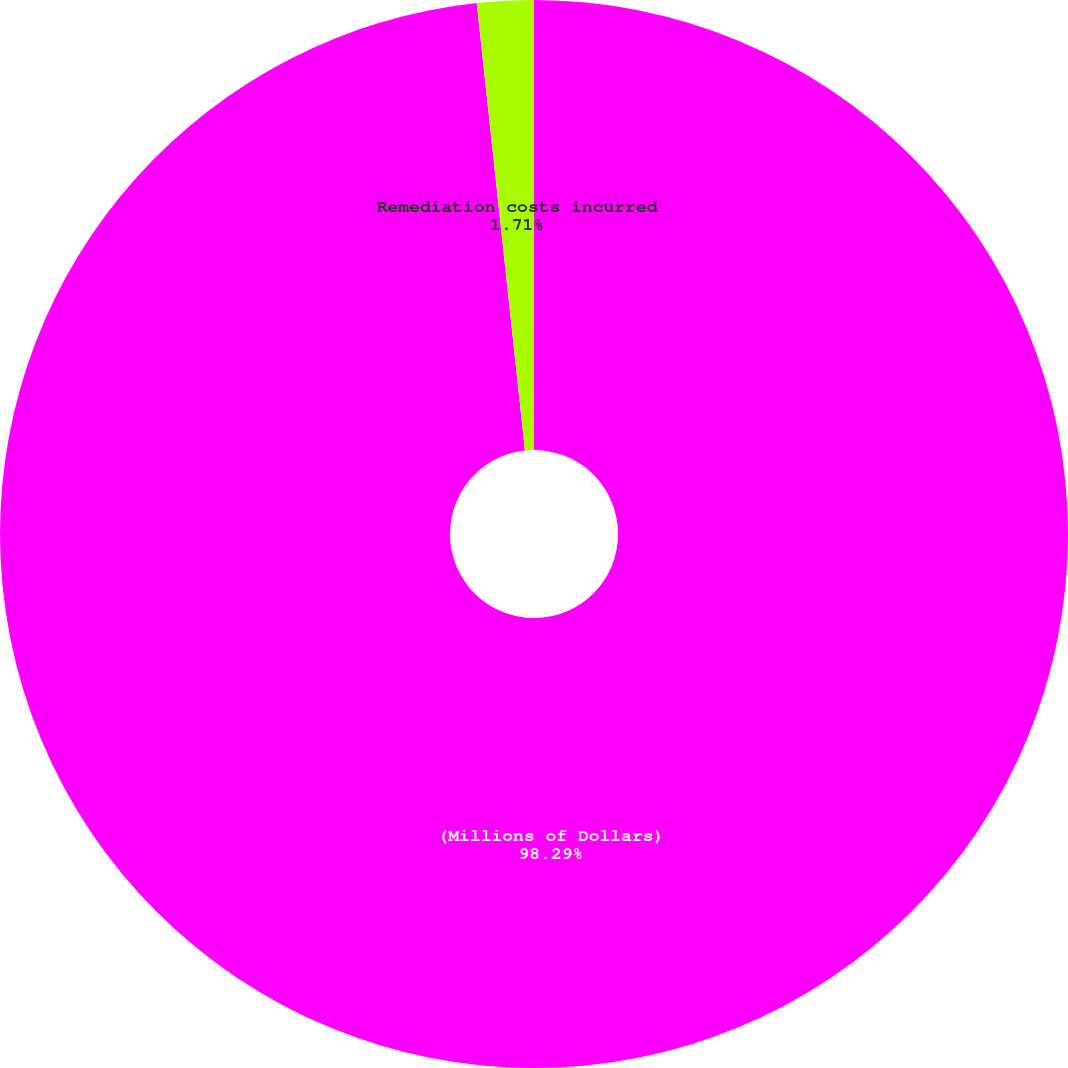Convert chart to OTSL. <chart><loc_0><loc_0><loc_500><loc_500><pie_chart><fcel>(Millions of Dollars)<fcel>Remediation costs incurred<nl><fcel>98.29%<fcel>1.71%<nl></chart> 